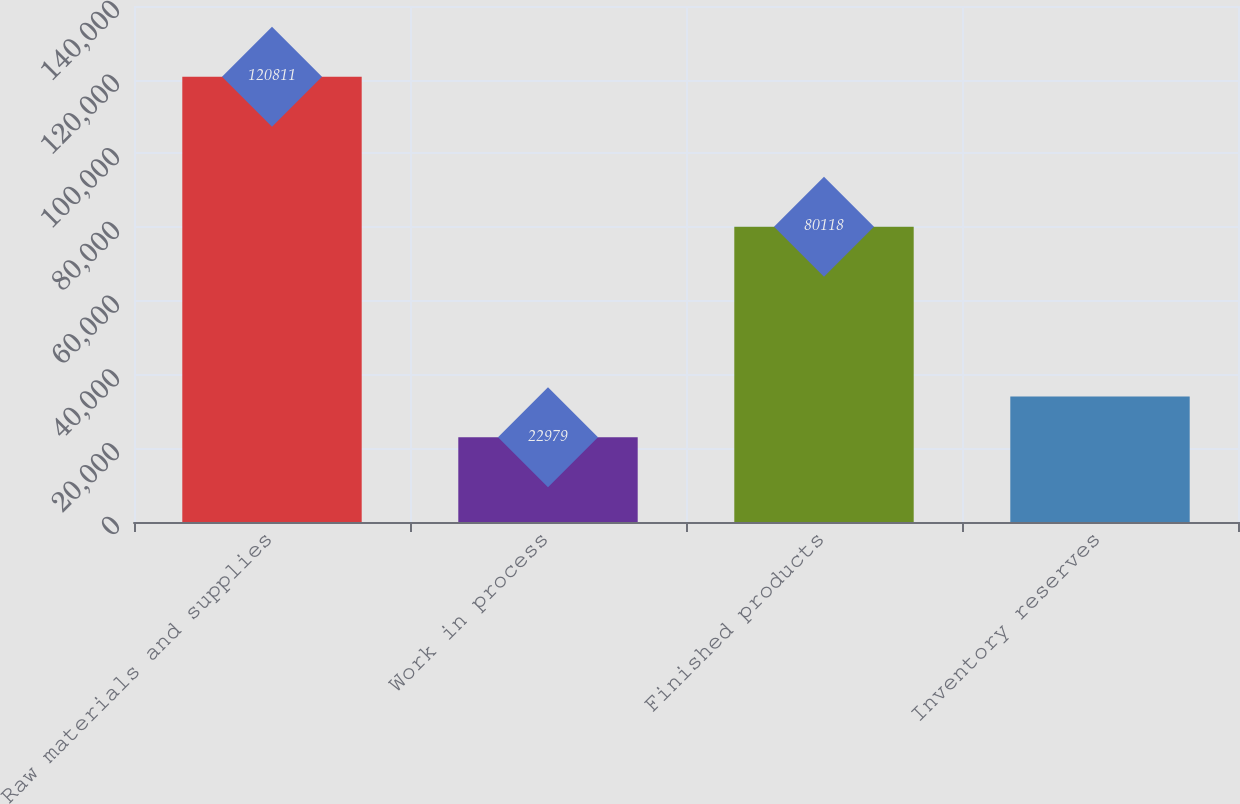Convert chart to OTSL. <chart><loc_0><loc_0><loc_500><loc_500><bar_chart><fcel>Raw materials and supplies<fcel>Work in process<fcel>Finished products<fcel>Inventory reserves<nl><fcel>120811<fcel>22979<fcel>80118<fcel>34040<nl></chart> 